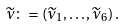Convert formula to latex. <formula><loc_0><loc_0><loc_500><loc_500>\widetilde { \nu } \colon = \left ( \widetilde { \nu } _ { 1 } , \dots , \widetilde { \nu } _ { 6 } \right ) .</formula> 